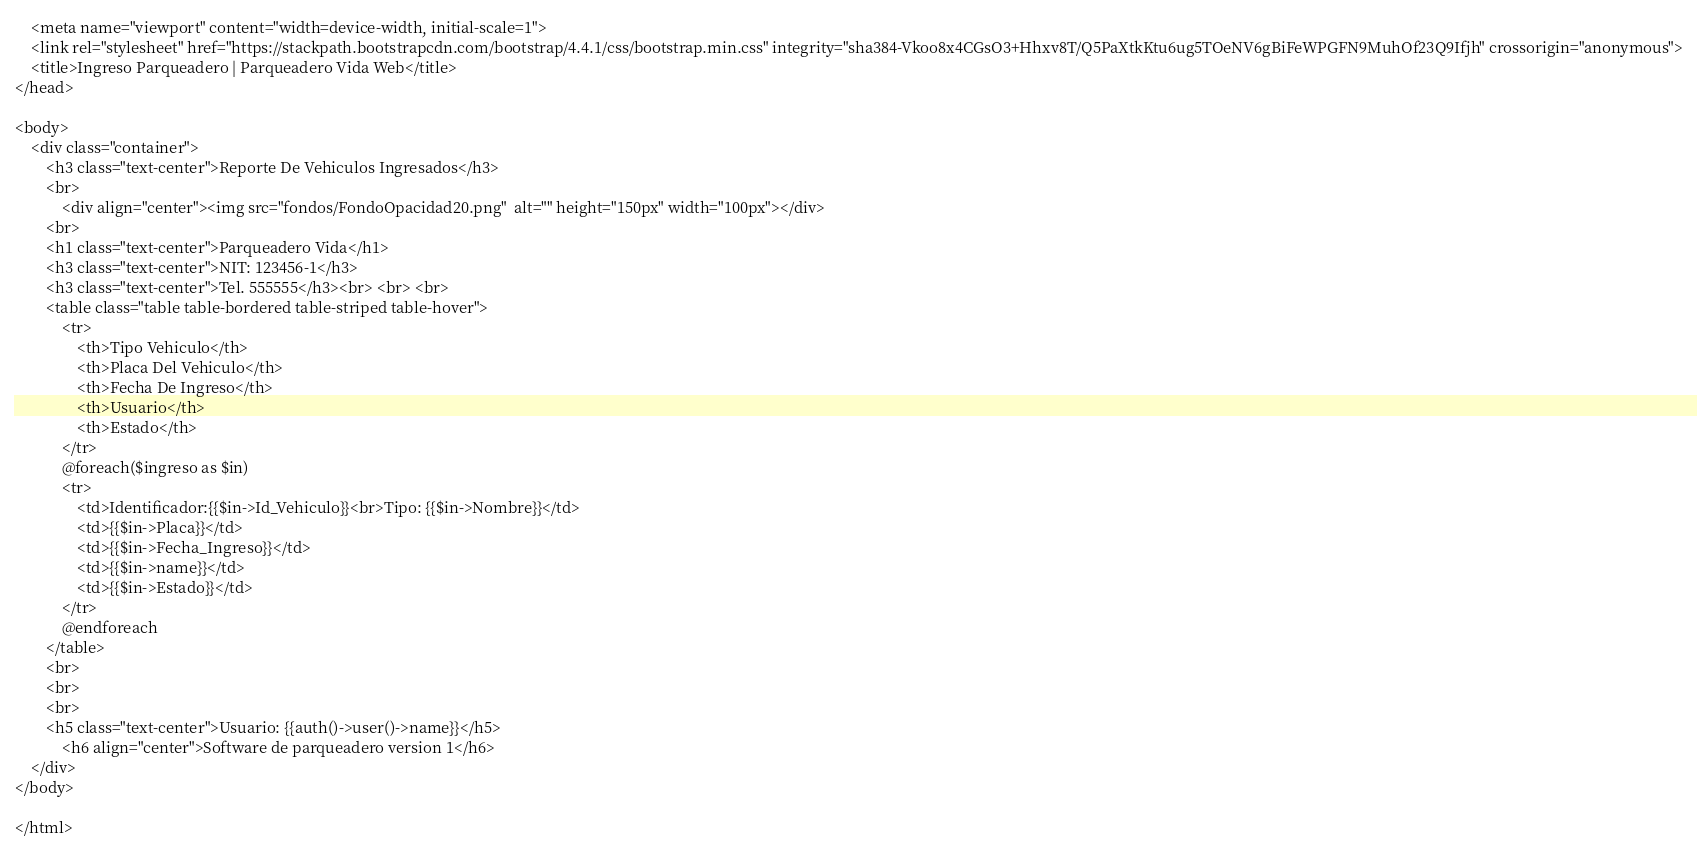Convert code to text. <code><loc_0><loc_0><loc_500><loc_500><_PHP_>    <meta name="viewport" content="width=device-width, initial-scale=1">
    <link rel="stylesheet" href="https://stackpath.bootstrapcdn.com/bootstrap/4.4.1/css/bootstrap.min.css" integrity="sha384-Vkoo8x4CGsO3+Hhxv8T/Q5PaXtkKtu6ug5TOeNV6gBiFeWPGFN9MuhOf23Q9Ifjh" crossorigin="anonymous">
    <title>Ingreso Parqueadero | Parqueadero Vida Web</title>
</head>

<body>
    <div class="container">
        <h3 class="text-center">Reporte De Vehiculos Ingresados</h3>
        <br>
            <div align="center"><img src="fondos/FondoOpacidad20.png"  alt="" height="150px" width="100px"></div>
        <br>
        <h1 class="text-center">Parqueadero Vida</h1>
        <h3 class="text-center">NIT: 123456-1</h3>
        <h3 class="text-center">Tel. 555555</h3><br> <br> <br>
        <table class="table table-bordered table-striped table-hover">
            <tr>
                <th>Tipo Vehiculo</th>
                <th>Placa Del Vehiculo</th>
                <th>Fecha De Ingreso</th>
                <th>Usuario</th>
                <th>Estado</th>
            </tr>
            @foreach($ingreso as $in)
            <tr>
                <td>Identificador:{{$in->Id_Vehiculo}}<br>Tipo: {{$in->Nombre}}</td>
                <td>{{$in->Placa}}</td>
                <td>{{$in->Fecha_Ingreso}}</td>
                <td>{{$in->name}}</td>
                <td>{{$in->Estado}}</td>        
            </tr>
            @endforeach
        </table>
        <br>
        <br>
        <br>
        <h5 class="text-center">Usuario: {{auth()->user()->name}}</h5>
            <h6 align="center">Software de parqueadero version 1</h6>
    </div>
</body>

</html></code> 